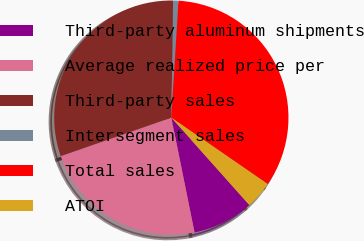Convert chart. <chart><loc_0><loc_0><loc_500><loc_500><pie_chart><fcel>Third-party aluminum shipments<fcel>Average realized price per<fcel>Third-party sales<fcel>Intersegment sales<fcel>Total sales<fcel>ATOI<nl><fcel>8.42%<fcel>22.84%<fcel>30.57%<fcel>0.74%<fcel>33.63%<fcel>3.8%<nl></chart> 